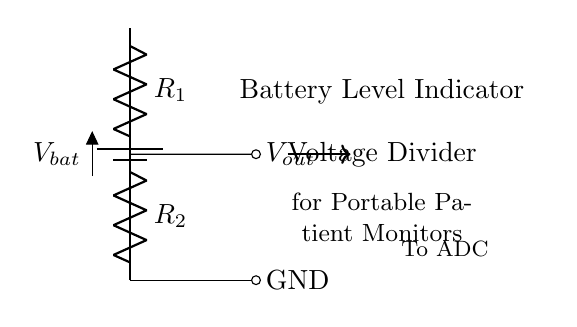What does the circuit indicate? The circuit serves as a battery level indicator, showing the status of the battery voltage for the portable patient monitor.
Answer: Battery Level Indicator What are the components used in the circuit? The circuit contains a battery and two resistors labeled R1 and R2, which form the voltage divider.
Answer: Battery, R1, R2 What is the output voltage in this type of circuit? The output voltage, denoted as Vout, is measured at the junction between R1 and R2 and represents a fraction of the battery voltage depending on the resistor values.
Answer: Vout How do R1 and R2 affect the output voltage? R1 and R2 distribute the input voltage according to their resistance values, determining how much voltage drops across each component; Vout is calculated based on their values.
Answer: They divide the voltage What happens if R1 is increased? Increasing R1 will lead to a decrease in Vout, as a larger portion of the input voltage will drop across R1 and less across R2.
Answer: Vout decreases What is the purpose of the ADC connection in the circuit? The ADC (Analog to Digital Converter) is used to convert the output voltage Vout into a digital format so that the battery level can be processed and displayed on the monitor.
Answer: To convert Vout to digital 